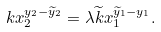<formula> <loc_0><loc_0><loc_500><loc_500>k x _ { 2 } ^ { y _ { 2 } - \widetilde { y } _ { 2 } } & = \lambda \widetilde { k } x _ { 1 } ^ { \widetilde { y } _ { 1 } - y _ { 1 } } .</formula> 